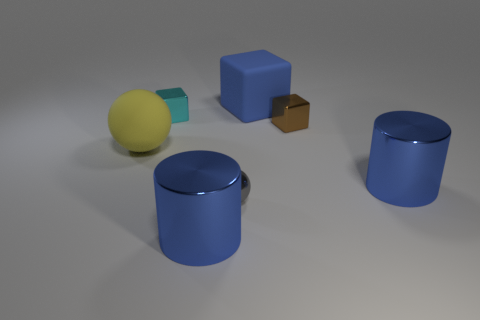What number of balls are left of the small gray sphere and in front of the big yellow ball?
Your response must be concise. 0. There is a small cyan object that is the same shape as the tiny brown metallic object; what material is it?
Give a very brief answer. Metal. Are there the same number of tiny gray spheres that are to the left of the large yellow ball and big spheres that are behind the small brown metallic block?
Your answer should be very brief. Yes. Are the brown block and the small cyan block made of the same material?
Give a very brief answer. Yes. What number of blue things are metal cylinders or rubber balls?
Your answer should be very brief. 2. What number of large things have the same shape as the small gray metal object?
Give a very brief answer. 1. What material is the small cyan block?
Your response must be concise. Metal. Are there an equal number of metal things left of the brown metal object and small objects?
Your response must be concise. Yes. The gray object that is the same size as the brown thing is what shape?
Your answer should be very brief. Sphere. Are there any things that are on the right side of the large matte thing to the left of the cyan metallic block?
Provide a short and direct response. Yes. 